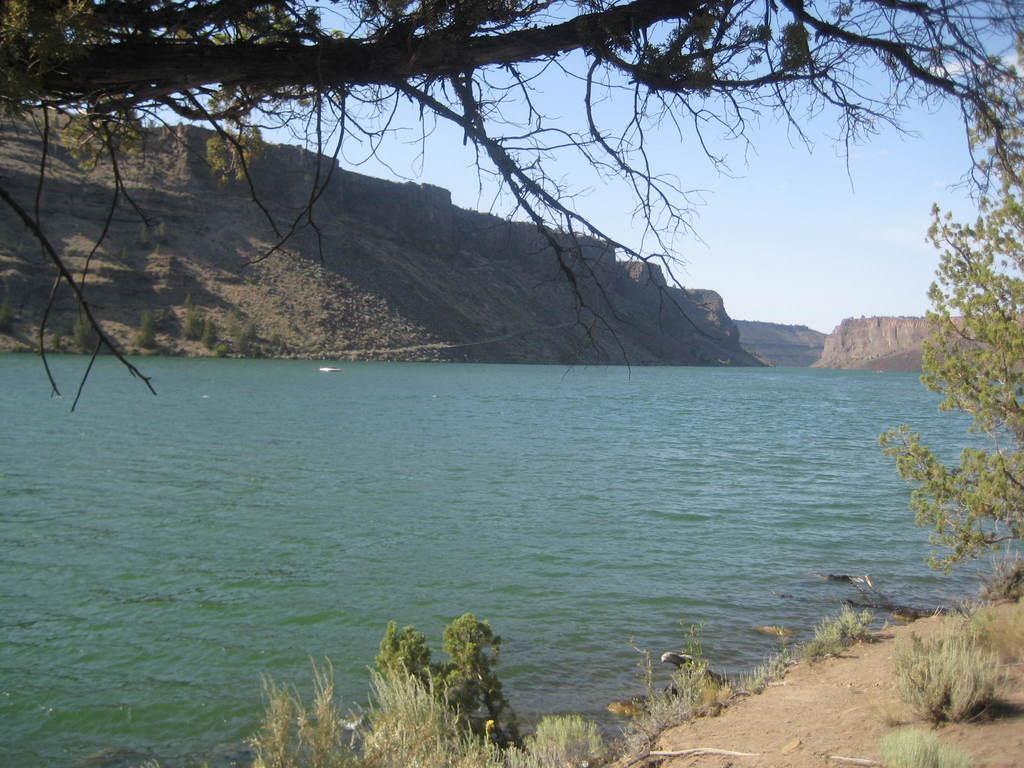Describe this image in one or two sentences. In the forehand of the picture there are trees, shrubs and soil. In the center of the picture there is a water body. In the background there are mountains. Sky is sunny. 